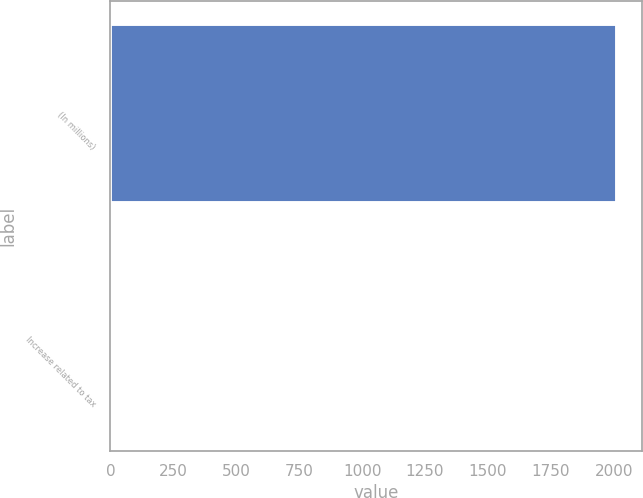Convert chart. <chart><loc_0><loc_0><loc_500><loc_500><bar_chart><fcel>(In millions)<fcel>Increase related to tax<nl><fcel>2012<fcel>2<nl></chart> 